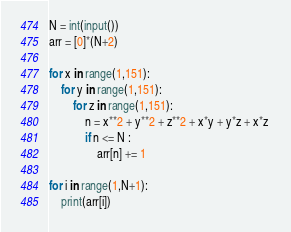Convert code to text. <code><loc_0><loc_0><loc_500><loc_500><_Python_>N = int(input())
arr = [0]*(N+2)
 
for x in range(1,151):
    for y in range(1,151):
        for z in range(1,151):
            n = x**2 + y**2 + z**2 + x*y + y*z + x*z 
            if n <= N :
                arr[n] += 1
 
for i in range(1,N+1):
    print(arr[i])</code> 